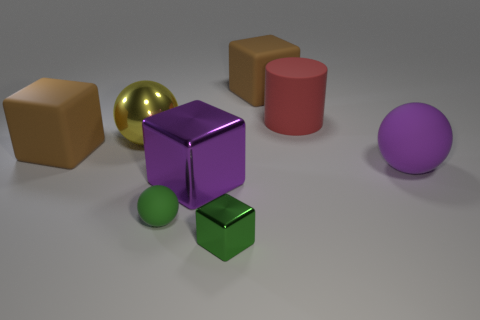Can you describe the variety of colors seen among the objects in the image? Certainly! In the image, there is a spectrum of colors on display among the objects. There's a gold sphere, a violet sphere, a purple cube, a green sphere, a red cylinder, and a brown cube. These colors add a vibrant contrast to the neutral background. Which of these objects are spheres? There are three spherical objects in the image: one gold, one green, and one violet. They all reflect light differently, showcasing their various materials. 